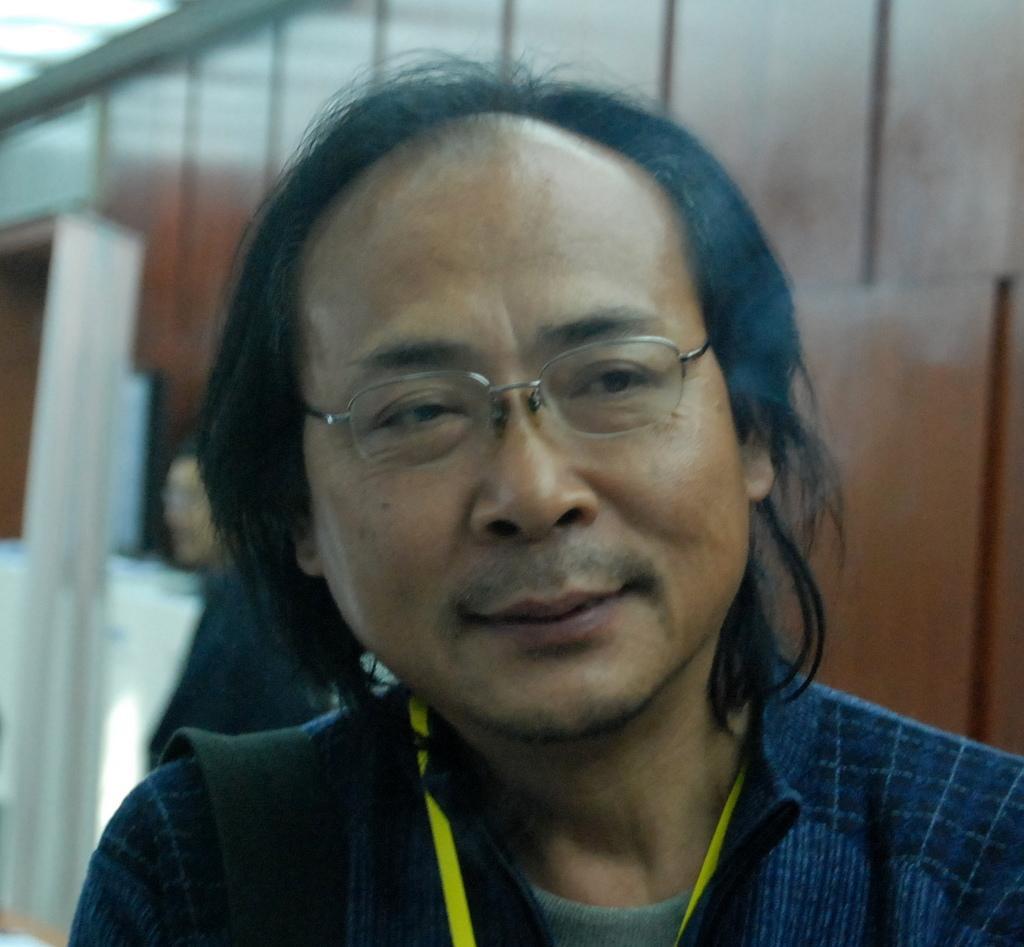Please provide a concise description of this image. Here I can see a man smiling and looking at the right side. At the back of him there is another person. On the left side, I can see white color objects. In the background there is a wooden wall. 